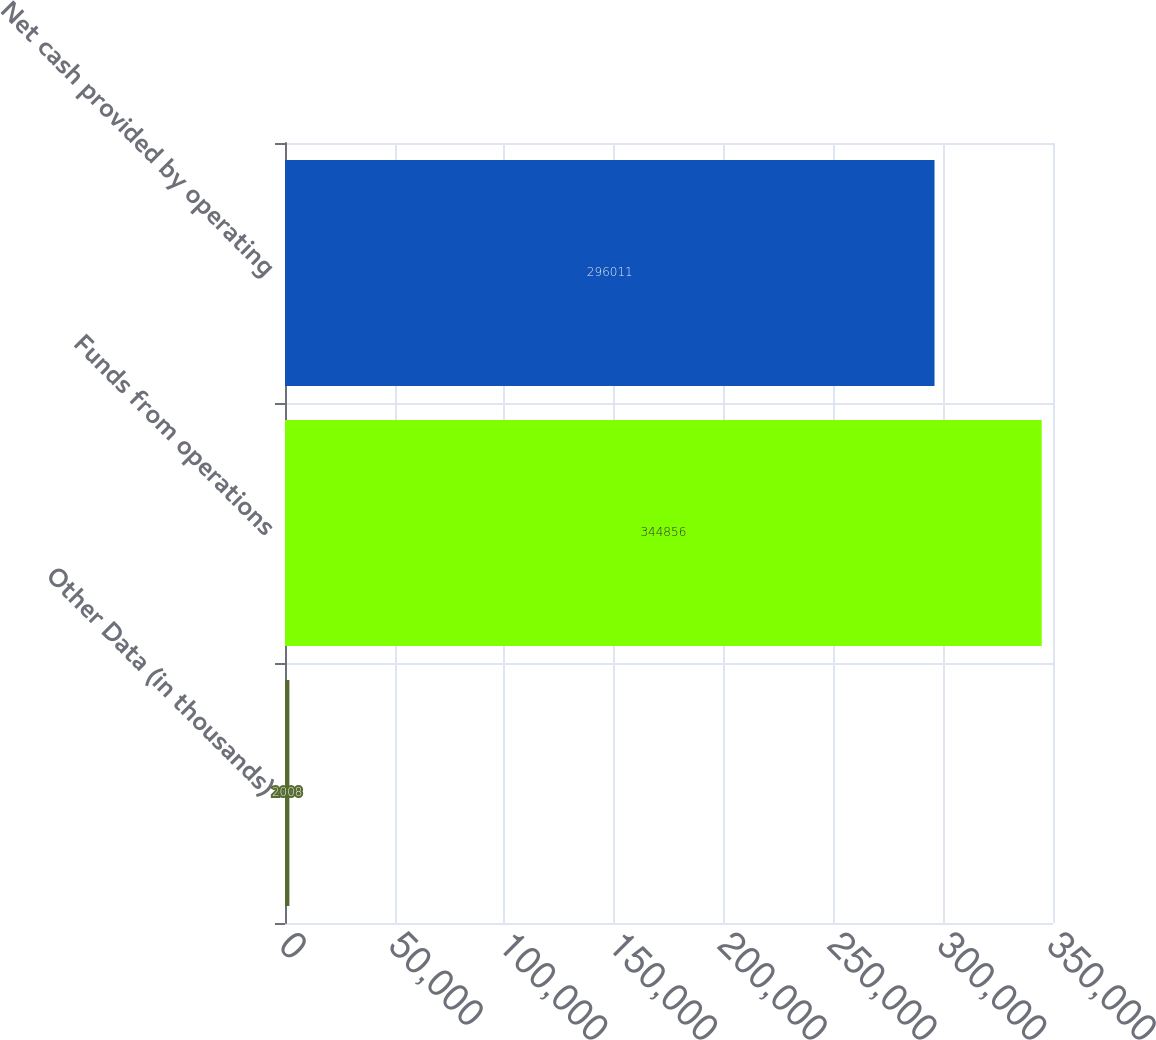<chart> <loc_0><loc_0><loc_500><loc_500><bar_chart><fcel>Other Data (in thousands)<fcel>Funds from operations<fcel>Net cash provided by operating<nl><fcel>2008<fcel>344856<fcel>296011<nl></chart> 